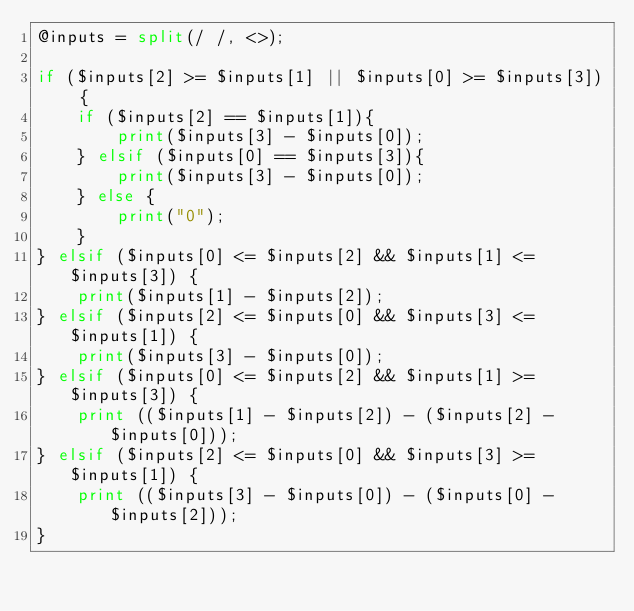<code> <loc_0><loc_0><loc_500><loc_500><_Perl_>@inputs = split(/ /, <>);

if ($inputs[2] >= $inputs[1] || $inputs[0] >= $inputs[3]) {
    if ($inputs[2] == $inputs[1]){
        print($inputs[3] - $inputs[0]);
    } elsif ($inputs[0] == $inputs[3]){
        print($inputs[3] - $inputs[0]);
    } else {
        print("0");
    }
} elsif ($inputs[0] <= $inputs[2] && $inputs[1] <= $inputs[3]) {
    print($inputs[1] - $inputs[2]);
} elsif ($inputs[2] <= $inputs[0] && $inputs[3] <= $inputs[1]) {
    print($inputs[3] - $inputs[0]);
} elsif ($inputs[0] <= $inputs[2] && $inputs[1] >= $inputs[3]) {
    print (($inputs[1] - $inputs[2]) - ($inputs[2] - $inputs[0]));
} elsif ($inputs[2] <= $inputs[0] && $inputs[3] >= $inputs[1]) {
    print (($inputs[3] - $inputs[0]) - ($inputs[0] - $inputs[2]));
}</code> 